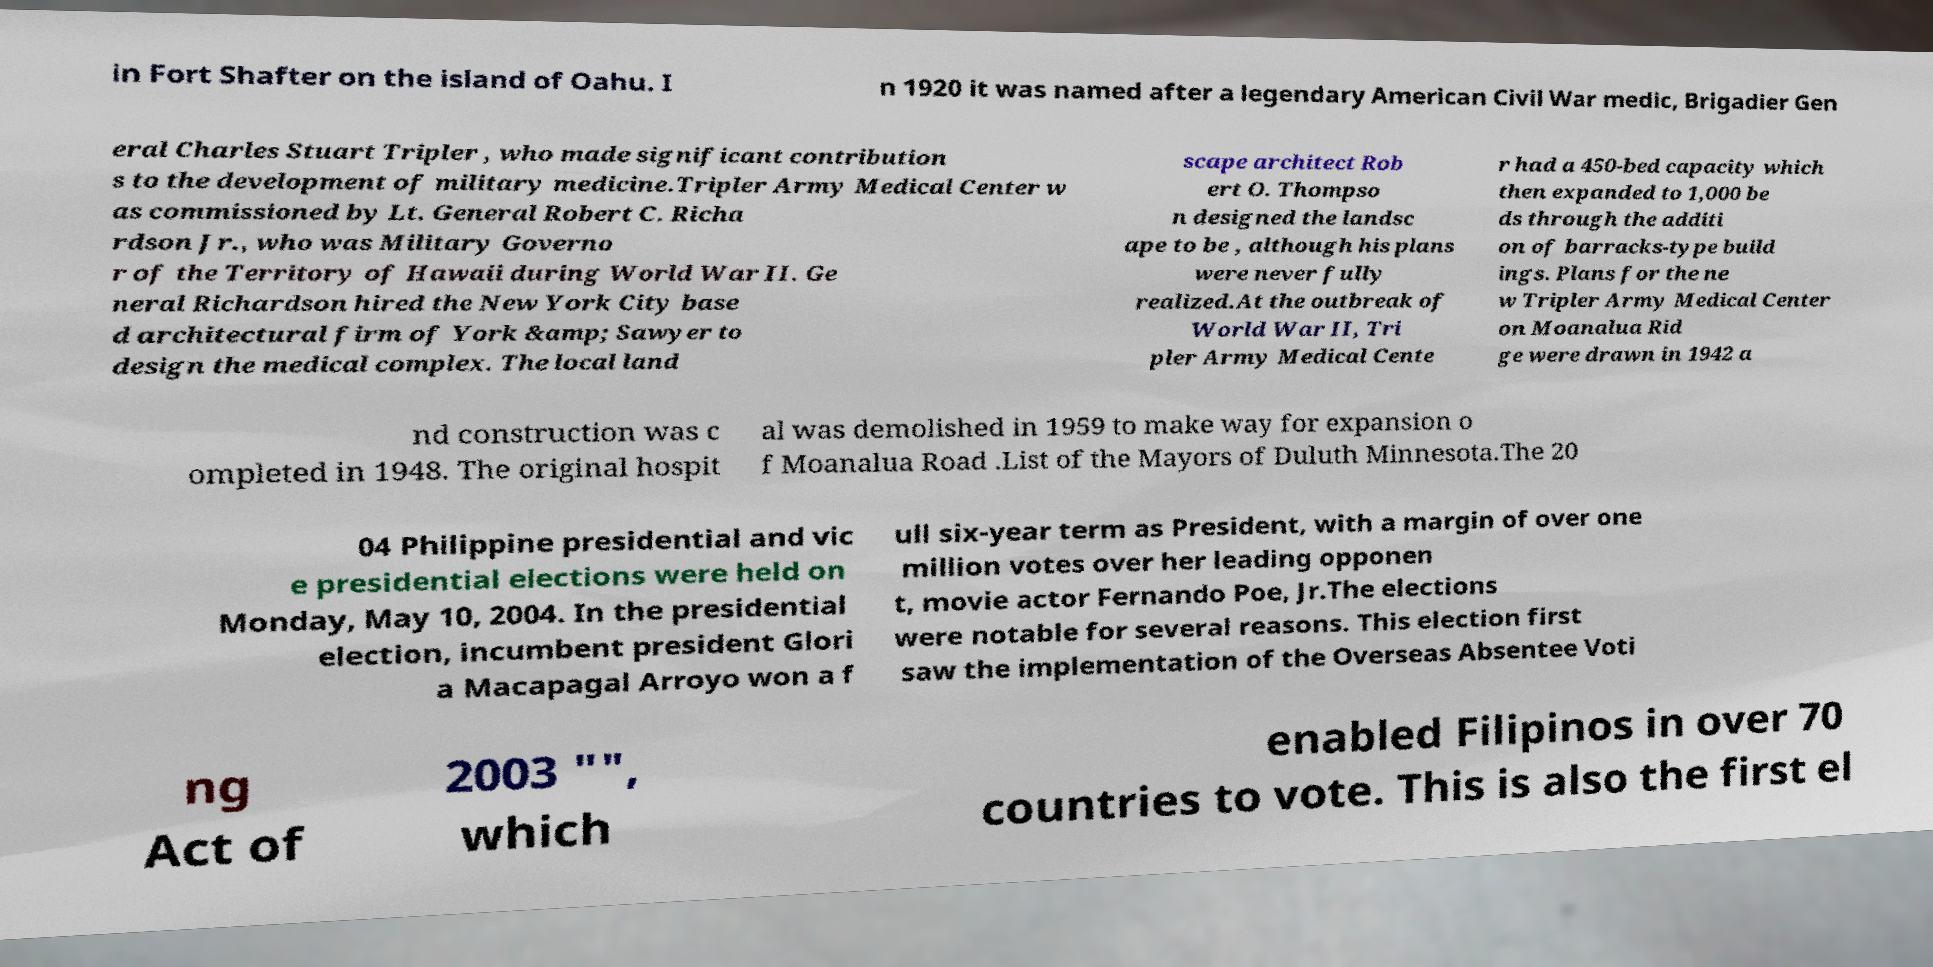I need the written content from this picture converted into text. Can you do that? in Fort Shafter on the island of Oahu. I n 1920 it was named after a legendary American Civil War medic, Brigadier Gen eral Charles Stuart Tripler , who made significant contribution s to the development of military medicine.Tripler Army Medical Center w as commissioned by Lt. General Robert C. Richa rdson Jr., who was Military Governo r of the Territory of Hawaii during World War II. Ge neral Richardson hired the New York City base d architectural firm of York &amp; Sawyer to design the medical complex. The local land scape architect Rob ert O. Thompso n designed the landsc ape to be , although his plans were never fully realized.At the outbreak of World War II, Tri pler Army Medical Cente r had a 450-bed capacity which then expanded to 1,000 be ds through the additi on of barracks-type build ings. Plans for the ne w Tripler Army Medical Center on Moanalua Rid ge were drawn in 1942 a nd construction was c ompleted in 1948. The original hospit al was demolished in 1959 to make way for expansion o f Moanalua Road .List of the Mayors of Duluth Minnesota.The 20 04 Philippine presidential and vic e presidential elections were held on Monday, May 10, 2004. In the presidential election, incumbent president Glori a Macapagal Arroyo won a f ull six-year term as President, with a margin of over one million votes over her leading opponen t, movie actor Fernando Poe, Jr.The elections were notable for several reasons. This election first saw the implementation of the Overseas Absentee Voti ng Act of 2003 "", which enabled Filipinos in over 70 countries to vote. This is also the first el 